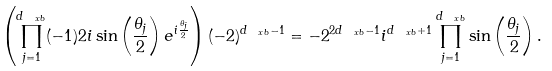<formula> <loc_0><loc_0><loc_500><loc_500>\left ( \prod _ { j = 1 } ^ { d _ { \ x b } } ( - 1 ) 2 i \sin \left ( \frac { \theta _ { j } } { 2 } \right ) e ^ { i \frac { \theta _ { j } } { 2 } } \right ) ( - 2 ) ^ { d _ { \ x b } - 1 } = - 2 ^ { 2 d _ { \ x b } - 1 } i ^ { d _ { \ x b } + 1 } \prod _ { j = 1 } ^ { d _ { \ x b } } \sin \left ( \frac { \theta _ { j } } { 2 } \right ) .</formula> 